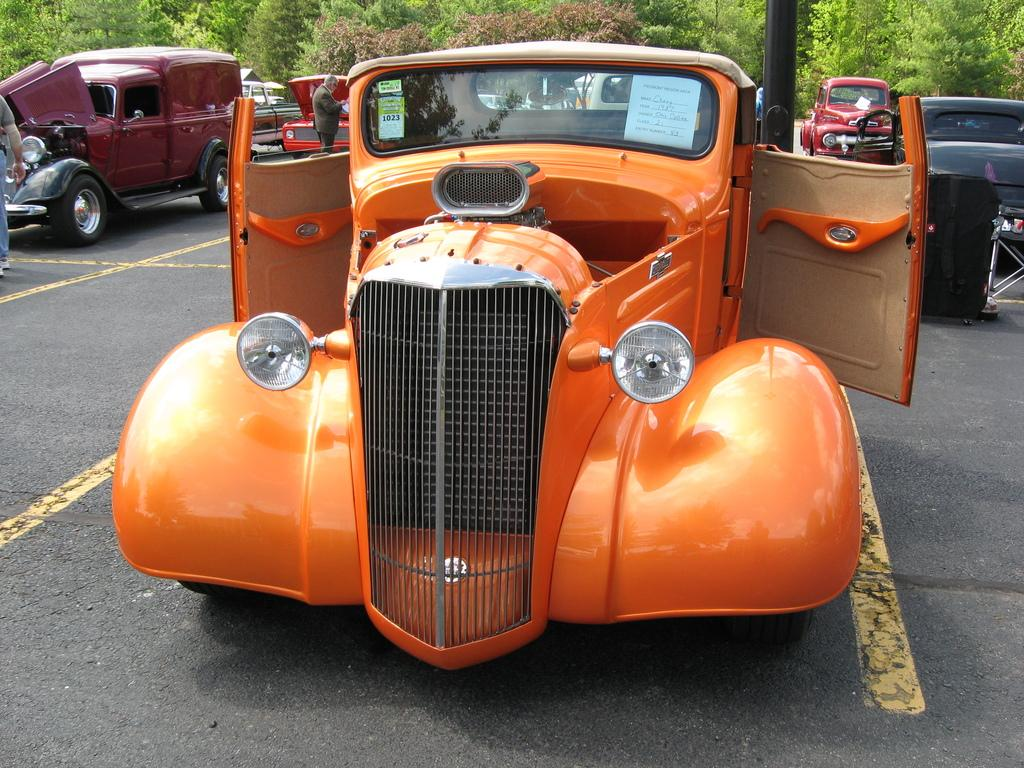What is the main subject in the foreground of the picture? There is a car in the foreground of the picture on the road. What can be seen in the center of the picture? In the center of the picture, there are cars, people, and a pole. What type of natural scenery is visible in the background of the image? There are trees visible in the background of the image. How many brothers are visible in the image? There is no mention of a brother or any people related by blood in the image. 